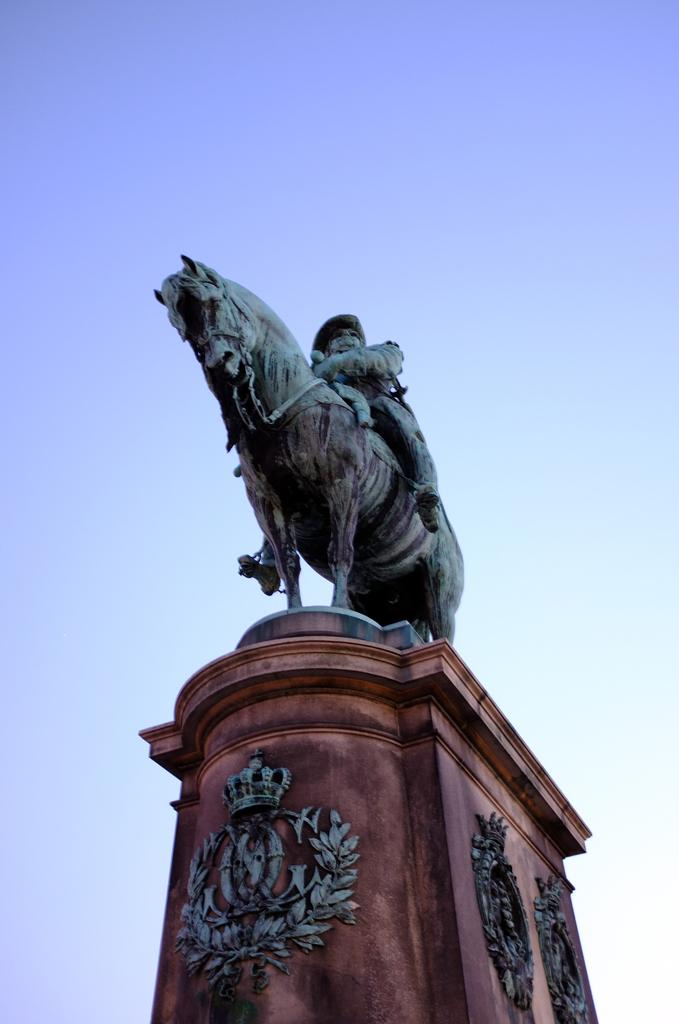What is the main subject in the image? There is a statue in the image. What is the statue standing on? There is a pedestal in the image. What can be seen in the background of the image? The sky is visible in the background of the image. What type of chicken is sitting on the statue's head in the image? There is no chicken present in the image; it only features a statue and a pedestal. 